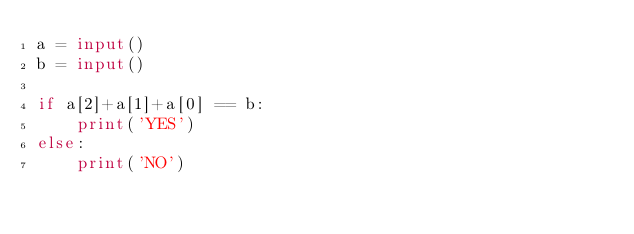Convert code to text. <code><loc_0><loc_0><loc_500><loc_500><_Python_>a = input()
b = input()

if a[2]+a[1]+a[0] == b:
    print('YES')
else:
    print('NO')
</code> 